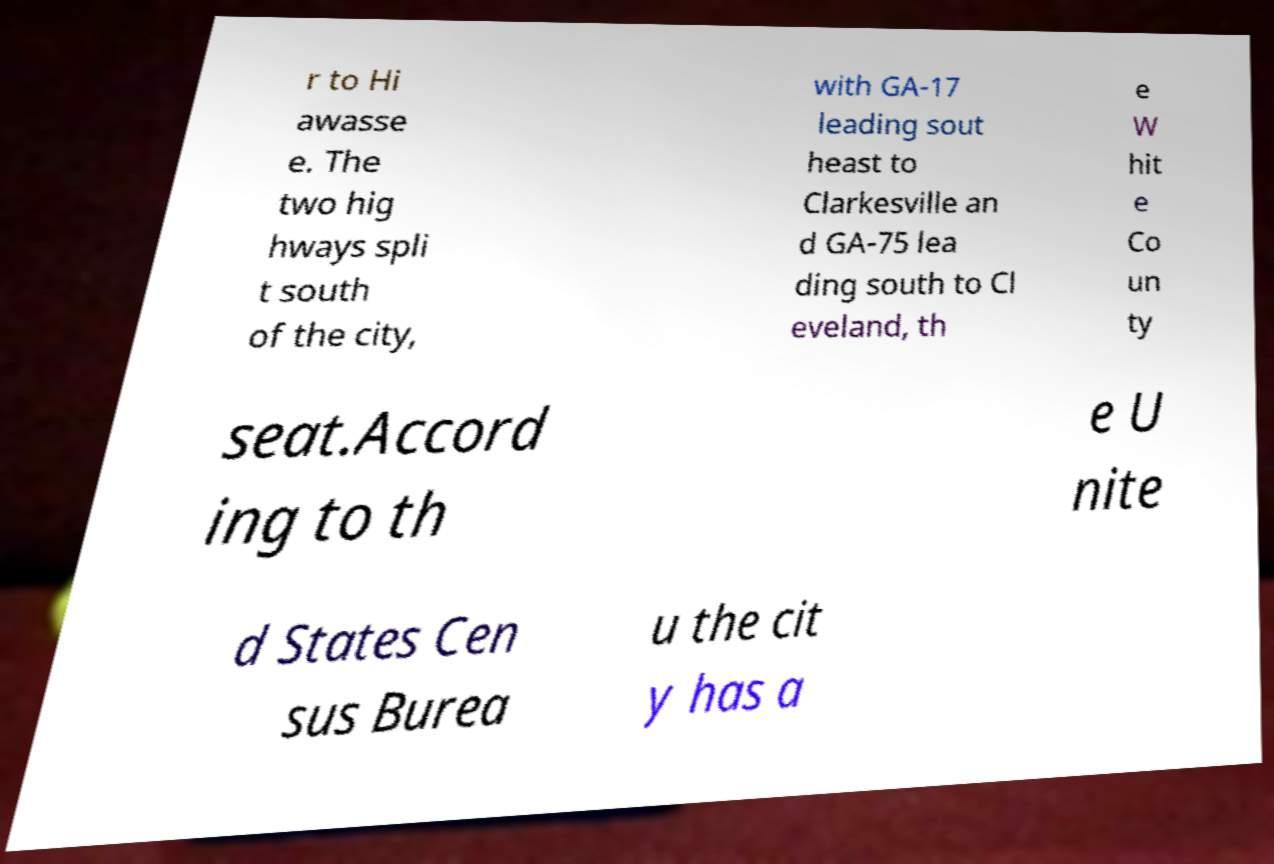What messages or text are displayed in this image? I need them in a readable, typed format. r to Hi awasse e. The two hig hways spli t south of the city, with GA-17 leading sout heast to Clarkesville an d GA-75 lea ding south to Cl eveland, th e W hit e Co un ty seat.Accord ing to th e U nite d States Cen sus Burea u the cit y has a 